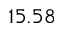Convert formula to latex. <formula><loc_0><loc_0><loc_500><loc_500>1 5 . 5 8</formula> 